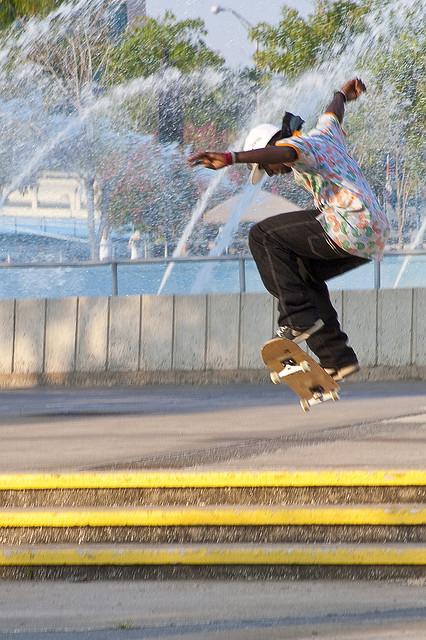What is throwing water in the background?
Concise answer only. Fountain. How many steps are there?
Short answer required. 3. What is he doing?
Quick response, please. Skateboarding. 